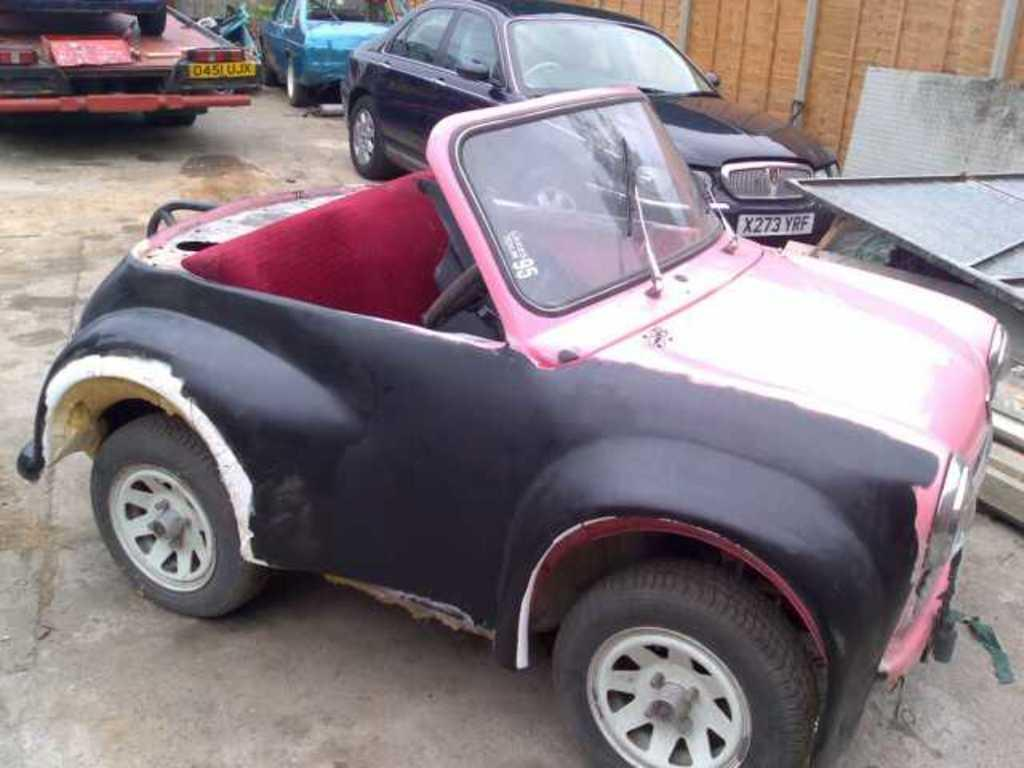What is the primary subject of the image? The primary subject of the image is many vehicles. Can you describe any other elements in the image? Yes, there is a wall in the image. What is the interest rate on the account shown in the image? There is no account or mention of interest rates in the image; it primarily features vehicles and a wall. 